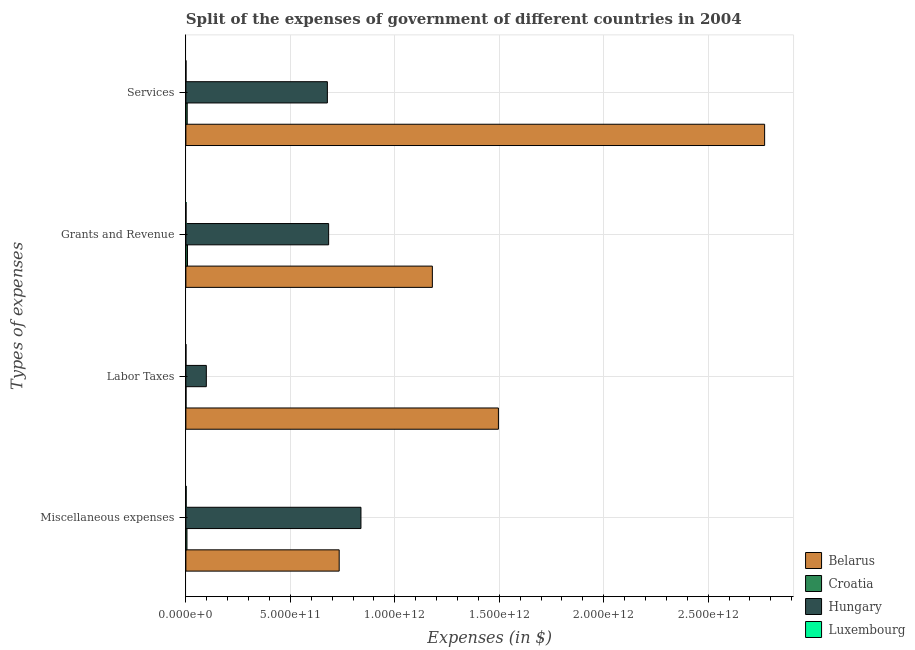How many different coloured bars are there?
Provide a succinct answer. 4. How many groups of bars are there?
Your answer should be compact. 4. Are the number of bars on each tick of the Y-axis equal?
Offer a terse response. Yes. What is the label of the 3rd group of bars from the top?
Provide a short and direct response. Labor Taxes. What is the amount spent on labor taxes in Croatia?
Your answer should be compact. 6.97e+08. Across all countries, what is the maximum amount spent on grants and revenue?
Keep it short and to the point. 1.18e+12. Across all countries, what is the minimum amount spent on services?
Your answer should be compact. 6.20e+08. In which country was the amount spent on grants and revenue maximum?
Your answer should be compact. Belarus. In which country was the amount spent on services minimum?
Ensure brevity in your answer.  Luxembourg. What is the total amount spent on grants and revenue in the graph?
Make the answer very short. 1.87e+12. What is the difference between the amount spent on labor taxes in Hungary and that in Croatia?
Your answer should be very brief. 9.72e+1. What is the difference between the amount spent on miscellaneous expenses in Luxembourg and the amount spent on services in Croatia?
Offer a terse response. -4.93e+09. What is the average amount spent on services per country?
Offer a very short reply. 8.64e+11. What is the difference between the amount spent on grants and revenue and amount spent on services in Croatia?
Your response must be concise. 1.38e+09. In how many countries, is the amount spent on miscellaneous expenses greater than 1000000000000 $?
Your response must be concise. 0. What is the ratio of the amount spent on miscellaneous expenses in Luxembourg to that in Hungary?
Your answer should be compact. 0. Is the amount spent on labor taxes in Belarus less than that in Croatia?
Provide a succinct answer. No. Is the difference between the amount spent on services in Croatia and Luxembourg greater than the difference between the amount spent on labor taxes in Croatia and Luxembourg?
Provide a succinct answer. Yes. What is the difference between the highest and the second highest amount spent on miscellaneous expenses?
Your response must be concise. 1.04e+11. What is the difference between the highest and the lowest amount spent on services?
Keep it short and to the point. 2.77e+12. In how many countries, is the amount spent on services greater than the average amount spent on services taken over all countries?
Offer a terse response. 1. Is the sum of the amount spent on miscellaneous expenses in Belarus and Luxembourg greater than the maximum amount spent on services across all countries?
Your response must be concise. No. Is it the case that in every country, the sum of the amount spent on grants and revenue and amount spent on miscellaneous expenses is greater than the sum of amount spent on labor taxes and amount spent on services?
Keep it short and to the point. Yes. What does the 1st bar from the top in Labor Taxes represents?
Provide a succinct answer. Luxembourg. What does the 1st bar from the bottom in Grants and Revenue represents?
Provide a succinct answer. Belarus. How many bars are there?
Your response must be concise. 16. What is the difference between two consecutive major ticks on the X-axis?
Ensure brevity in your answer.  5.00e+11. Are the values on the major ticks of X-axis written in scientific E-notation?
Provide a succinct answer. Yes. Does the graph contain any zero values?
Give a very brief answer. No. How many legend labels are there?
Provide a short and direct response. 4. How are the legend labels stacked?
Give a very brief answer. Vertical. What is the title of the graph?
Give a very brief answer. Split of the expenses of government of different countries in 2004. Does "Gabon" appear as one of the legend labels in the graph?
Offer a very short reply. No. What is the label or title of the X-axis?
Ensure brevity in your answer.  Expenses (in $). What is the label or title of the Y-axis?
Keep it short and to the point. Types of expenses. What is the Expenses (in $) of Belarus in Miscellaneous expenses?
Offer a very short reply. 7.34e+11. What is the Expenses (in $) in Croatia in Miscellaneous expenses?
Your answer should be very brief. 5.23e+09. What is the Expenses (in $) of Hungary in Miscellaneous expenses?
Offer a terse response. 8.38e+11. What is the Expenses (in $) in Luxembourg in Miscellaneous expenses?
Offer a terse response. 1.39e+09. What is the Expenses (in $) in Belarus in Labor Taxes?
Your answer should be compact. 1.50e+12. What is the Expenses (in $) of Croatia in Labor Taxes?
Keep it short and to the point. 6.97e+08. What is the Expenses (in $) in Hungary in Labor Taxes?
Provide a succinct answer. 9.79e+1. What is the Expenses (in $) in Luxembourg in Labor Taxes?
Provide a succinct answer. 3.72e+08. What is the Expenses (in $) of Belarus in Grants and Revenue?
Ensure brevity in your answer.  1.18e+12. What is the Expenses (in $) in Croatia in Grants and Revenue?
Give a very brief answer. 7.71e+09. What is the Expenses (in $) in Hungary in Grants and Revenue?
Make the answer very short. 6.83e+11. What is the Expenses (in $) in Luxembourg in Grants and Revenue?
Provide a succinct answer. 7.38e+08. What is the Expenses (in $) in Belarus in Services?
Provide a succinct answer. 2.77e+12. What is the Expenses (in $) of Croatia in Services?
Ensure brevity in your answer.  6.33e+09. What is the Expenses (in $) of Hungary in Services?
Your answer should be compact. 6.77e+11. What is the Expenses (in $) in Luxembourg in Services?
Provide a short and direct response. 6.20e+08. Across all Types of expenses, what is the maximum Expenses (in $) in Belarus?
Your response must be concise. 2.77e+12. Across all Types of expenses, what is the maximum Expenses (in $) in Croatia?
Provide a succinct answer. 7.71e+09. Across all Types of expenses, what is the maximum Expenses (in $) in Hungary?
Provide a short and direct response. 8.38e+11. Across all Types of expenses, what is the maximum Expenses (in $) in Luxembourg?
Ensure brevity in your answer.  1.39e+09. Across all Types of expenses, what is the minimum Expenses (in $) of Belarus?
Keep it short and to the point. 7.34e+11. Across all Types of expenses, what is the minimum Expenses (in $) of Croatia?
Your answer should be compact. 6.97e+08. Across all Types of expenses, what is the minimum Expenses (in $) in Hungary?
Your answer should be very brief. 9.79e+1. Across all Types of expenses, what is the minimum Expenses (in $) in Luxembourg?
Provide a succinct answer. 3.72e+08. What is the total Expenses (in $) of Belarus in the graph?
Make the answer very short. 6.18e+12. What is the total Expenses (in $) of Croatia in the graph?
Keep it short and to the point. 2.00e+1. What is the total Expenses (in $) in Hungary in the graph?
Offer a very short reply. 2.30e+12. What is the total Expenses (in $) in Luxembourg in the graph?
Your response must be concise. 3.12e+09. What is the difference between the Expenses (in $) in Belarus in Miscellaneous expenses and that in Labor Taxes?
Keep it short and to the point. -7.62e+11. What is the difference between the Expenses (in $) of Croatia in Miscellaneous expenses and that in Labor Taxes?
Make the answer very short. 4.53e+09. What is the difference between the Expenses (in $) in Hungary in Miscellaneous expenses and that in Labor Taxes?
Your answer should be very brief. 7.40e+11. What is the difference between the Expenses (in $) of Luxembourg in Miscellaneous expenses and that in Labor Taxes?
Your response must be concise. 1.02e+09. What is the difference between the Expenses (in $) of Belarus in Miscellaneous expenses and that in Grants and Revenue?
Offer a very short reply. -4.46e+11. What is the difference between the Expenses (in $) in Croatia in Miscellaneous expenses and that in Grants and Revenue?
Your response must be concise. -2.48e+09. What is the difference between the Expenses (in $) in Hungary in Miscellaneous expenses and that in Grants and Revenue?
Your answer should be compact. 1.55e+11. What is the difference between the Expenses (in $) of Luxembourg in Miscellaneous expenses and that in Grants and Revenue?
Offer a terse response. 6.57e+08. What is the difference between the Expenses (in $) of Belarus in Miscellaneous expenses and that in Services?
Keep it short and to the point. -2.04e+12. What is the difference between the Expenses (in $) in Croatia in Miscellaneous expenses and that in Services?
Make the answer very short. -1.10e+09. What is the difference between the Expenses (in $) in Hungary in Miscellaneous expenses and that in Services?
Give a very brief answer. 1.61e+11. What is the difference between the Expenses (in $) of Luxembourg in Miscellaneous expenses and that in Services?
Your answer should be very brief. 7.75e+08. What is the difference between the Expenses (in $) of Belarus in Labor Taxes and that in Grants and Revenue?
Your answer should be compact. 3.16e+11. What is the difference between the Expenses (in $) in Croatia in Labor Taxes and that in Grants and Revenue?
Ensure brevity in your answer.  -7.01e+09. What is the difference between the Expenses (in $) of Hungary in Labor Taxes and that in Grants and Revenue?
Your answer should be very brief. -5.86e+11. What is the difference between the Expenses (in $) of Luxembourg in Labor Taxes and that in Grants and Revenue?
Your answer should be very brief. -3.66e+08. What is the difference between the Expenses (in $) in Belarus in Labor Taxes and that in Services?
Keep it short and to the point. -1.27e+12. What is the difference between the Expenses (in $) of Croatia in Labor Taxes and that in Services?
Offer a terse response. -5.63e+09. What is the difference between the Expenses (in $) in Hungary in Labor Taxes and that in Services?
Offer a terse response. -5.79e+11. What is the difference between the Expenses (in $) of Luxembourg in Labor Taxes and that in Services?
Your answer should be compact. -2.48e+08. What is the difference between the Expenses (in $) of Belarus in Grants and Revenue and that in Services?
Your response must be concise. -1.59e+12. What is the difference between the Expenses (in $) in Croatia in Grants and Revenue and that in Services?
Keep it short and to the point. 1.38e+09. What is the difference between the Expenses (in $) of Hungary in Grants and Revenue and that in Services?
Provide a succinct answer. 6.04e+09. What is the difference between the Expenses (in $) in Luxembourg in Grants and Revenue and that in Services?
Your response must be concise. 1.18e+08. What is the difference between the Expenses (in $) of Belarus in Miscellaneous expenses and the Expenses (in $) of Croatia in Labor Taxes?
Offer a very short reply. 7.33e+11. What is the difference between the Expenses (in $) in Belarus in Miscellaneous expenses and the Expenses (in $) in Hungary in Labor Taxes?
Offer a very short reply. 6.36e+11. What is the difference between the Expenses (in $) of Belarus in Miscellaneous expenses and the Expenses (in $) of Luxembourg in Labor Taxes?
Your answer should be compact. 7.34e+11. What is the difference between the Expenses (in $) of Croatia in Miscellaneous expenses and the Expenses (in $) of Hungary in Labor Taxes?
Offer a very short reply. -9.27e+1. What is the difference between the Expenses (in $) in Croatia in Miscellaneous expenses and the Expenses (in $) in Luxembourg in Labor Taxes?
Your answer should be very brief. 4.86e+09. What is the difference between the Expenses (in $) of Hungary in Miscellaneous expenses and the Expenses (in $) of Luxembourg in Labor Taxes?
Provide a short and direct response. 8.38e+11. What is the difference between the Expenses (in $) in Belarus in Miscellaneous expenses and the Expenses (in $) in Croatia in Grants and Revenue?
Your answer should be compact. 7.26e+11. What is the difference between the Expenses (in $) of Belarus in Miscellaneous expenses and the Expenses (in $) of Hungary in Grants and Revenue?
Provide a succinct answer. 5.05e+1. What is the difference between the Expenses (in $) of Belarus in Miscellaneous expenses and the Expenses (in $) of Luxembourg in Grants and Revenue?
Your answer should be very brief. 7.33e+11. What is the difference between the Expenses (in $) in Croatia in Miscellaneous expenses and the Expenses (in $) in Hungary in Grants and Revenue?
Give a very brief answer. -6.78e+11. What is the difference between the Expenses (in $) in Croatia in Miscellaneous expenses and the Expenses (in $) in Luxembourg in Grants and Revenue?
Provide a short and direct response. 4.49e+09. What is the difference between the Expenses (in $) in Hungary in Miscellaneous expenses and the Expenses (in $) in Luxembourg in Grants and Revenue?
Offer a terse response. 8.37e+11. What is the difference between the Expenses (in $) of Belarus in Miscellaneous expenses and the Expenses (in $) of Croatia in Services?
Offer a terse response. 7.28e+11. What is the difference between the Expenses (in $) in Belarus in Miscellaneous expenses and the Expenses (in $) in Hungary in Services?
Provide a short and direct response. 5.65e+1. What is the difference between the Expenses (in $) of Belarus in Miscellaneous expenses and the Expenses (in $) of Luxembourg in Services?
Provide a short and direct response. 7.33e+11. What is the difference between the Expenses (in $) of Croatia in Miscellaneous expenses and the Expenses (in $) of Hungary in Services?
Give a very brief answer. -6.72e+11. What is the difference between the Expenses (in $) in Croatia in Miscellaneous expenses and the Expenses (in $) in Luxembourg in Services?
Offer a very short reply. 4.61e+09. What is the difference between the Expenses (in $) in Hungary in Miscellaneous expenses and the Expenses (in $) in Luxembourg in Services?
Ensure brevity in your answer.  8.37e+11. What is the difference between the Expenses (in $) in Belarus in Labor Taxes and the Expenses (in $) in Croatia in Grants and Revenue?
Your answer should be very brief. 1.49e+12. What is the difference between the Expenses (in $) of Belarus in Labor Taxes and the Expenses (in $) of Hungary in Grants and Revenue?
Offer a very short reply. 8.13e+11. What is the difference between the Expenses (in $) in Belarus in Labor Taxes and the Expenses (in $) in Luxembourg in Grants and Revenue?
Your answer should be very brief. 1.50e+12. What is the difference between the Expenses (in $) of Croatia in Labor Taxes and the Expenses (in $) of Hungary in Grants and Revenue?
Your answer should be very brief. -6.83e+11. What is the difference between the Expenses (in $) of Croatia in Labor Taxes and the Expenses (in $) of Luxembourg in Grants and Revenue?
Offer a very short reply. -4.07e+07. What is the difference between the Expenses (in $) in Hungary in Labor Taxes and the Expenses (in $) in Luxembourg in Grants and Revenue?
Your answer should be compact. 9.72e+1. What is the difference between the Expenses (in $) of Belarus in Labor Taxes and the Expenses (in $) of Croatia in Services?
Your answer should be compact. 1.49e+12. What is the difference between the Expenses (in $) of Belarus in Labor Taxes and the Expenses (in $) of Hungary in Services?
Offer a terse response. 8.19e+11. What is the difference between the Expenses (in $) in Belarus in Labor Taxes and the Expenses (in $) in Luxembourg in Services?
Offer a very short reply. 1.50e+12. What is the difference between the Expenses (in $) in Croatia in Labor Taxes and the Expenses (in $) in Hungary in Services?
Offer a very short reply. -6.77e+11. What is the difference between the Expenses (in $) of Croatia in Labor Taxes and the Expenses (in $) of Luxembourg in Services?
Keep it short and to the point. 7.73e+07. What is the difference between the Expenses (in $) in Hungary in Labor Taxes and the Expenses (in $) in Luxembourg in Services?
Offer a very short reply. 9.73e+1. What is the difference between the Expenses (in $) of Belarus in Grants and Revenue and the Expenses (in $) of Croatia in Services?
Provide a short and direct response. 1.17e+12. What is the difference between the Expenses (in $) in Belarus in Grants and Revenue and the Expenses (in $) in Hungary in Services?
Keep it short and to the point. 5.03e+11. What is the difference between the Expenses (in $) in Belarus in Grants and Revenue and the Expenses (in $) in Luxembourg in Services?
Keep it short and to the point. 1.18e+12. What is the difference between the Expenses (in $) in Croatia in Grants and Revenue and the Expenses (in $) in Hungary in Services?
Keep it short and to the point. -6.70e+11. What is the difference between the Expenses (in $) in Croatia in Grants and Revenue and the Expenses (in $) in Luxembourg in Services?
Provide a succinct answer. 7.09e+09. What is the difference between the Expenses (in $) of Hungary in Grants and Revenue and the Expenses (in $) of Luxembourg in Services?
Ensure brevity in your answer.  6.83e+11. What is the average Expenses (in $) in Belarus per Types of expenses?
Your answer should be very brief. 1.55e+12. What is the average Expenses (in $) of Croatia per Types of expenses?
Offer a very short reply. 4.99e+09. What is the average Expenses (in $) of Hungary per Types of expenses?
Offer a very short reply. 5.74e+11. What is the average Expenses (in $) in Luxembourg per Types of expenses?
Make the answer very short. 7.81e+08. What is the difference between the Expenses (in $) in Belarus and Expenses (in $) in Croatia in Miscellaneous expenses?
Ensure brevity in your answer.  7.29e+11. What is the difference between the Expenses (in $) in Belarus and Expenses (in $) in Hungary in Miscellaneous expenses?
Offer a very short reply. -1.04e+11. What is the difference between the Expenses (in $) in Belarus and Expenses (in $) in Luxembourg in Miscellaneous expenses?
Give a very brief answer. 7.33e+11. What is the difference between the Expenses (in $) of Croatia and Expenses (in $) of Hungary in Miscellaneous expenses?
Make the answer very short. -8.33e+11. What is the difference between the Expenses (in $) in Croatia and Expenses (in $) in Luxembourg in Miscellaneous expenses?
Provide a succinct answer. 3.83e+09. What is the difference between the Expenses (in $) in Hungary and Expenses (in $) in Luxembourg in Miscellaneous expenses?
Your answer should be compact. 8.37e+11. What is the difference between the Expenses (in $) of Belarus and Expenses (in $) of Croatia in Labor Taxes?
Your answer should be very brief. 1.50e+12. What is the difference between the Expenses (in $) in Belarus and Expenses (in $) in Hungary in Labor Taxes?
Make the answer very short. 1.40e+12. What is the difference between the Expenses (in $) of Belarus and Expenses (in $) of Luxembourg in Labor Taxes?
Offer a very short reply. 1.50e+12. What is the difference between the Expenses (in $) in Croatia and Expenses (in $) in Hungary in Labor Taxes?
Your response must be concise. -9.72e+1. What is the difference between the Expenses (in $) of Croatia and Expenses (in $) of Luxembourg in Labor Taxes?
Keep it short and to the point. 3.26e+08. What is the difference between the Expenses (in $) in Hungary and Expenses (in $) in Luxembourg in Labor Taxes?
Offer a terse response. 9.75e+1. What is the difference between the Expenses (in $) of Belarus and Expenses (in $) of Croatia in Grants and Revenue?
Your response must be concise. 1.17e+12. What is the difference between the Expenses (in $) in Belarus and Expenses (in $) in Hungary in Grants and Revenue?
Your answer should be very brief. 4.96e+11. What is the difference between the Expenses (in $) in Belarus and Expenses (in $) in Luxembourg in Grants and Revenue?
Your answer should be very brief. 1.18e+12. What is the difference between the Expenses (in $) in Croatia and Expenses (in $) in Hungary in Grants and Revenue?
Your answer should be very brief. -6.76e+11. What is the difference between the Expenses (in $) of Croatia and Expenses (in $) of Luxembourg in Grants and Revenue?
Make the answer very short. 6.97e+09. What is the difference between the Expenses (in $) in Hungary and Expenses (in $) in Luxembourg in Grants and Revenue?
Offer a terse response. 6.83e+11. What is the difference between the Expenses (in $) of Belarus and Expenses (in $) of Croatia in Services?
Make the answer very short. 2.76e+12. What is the difference between the Expenses (in $) of Belarus and Expenses (in $) of Hungary in Services?
Give a very brief answer. 2.09e+12. What is the difference between the Expenses (in $) of Belarus and Expenses (in $) of Luxembourg in Services?
Provide a short and direct response. 2.77e+12. What is the difference between the Expenses (in $) in Croatia and Expenses (in $) in Hungary in Services?
Your answer should be compact. -6.71e+11. What is the difference between the Expenses (in $) of Croatia and Expenses (in $) of Luxembourg in Services?
Provide a short and direct response. 5.71e+09. What is the difference between the Expenses (in $) in Hungary and Expenses (in $) in Luxembourg in Services?
Your answer should be very brief. 6.77e+11. What is the ratio of the Expenses (in $) in Belarus in Miscellaneous expenses to that in Labor Taxes?
Your response must be concise. 0.49. What is the ratio of the Expenses (in $) in Croatia in Miscellaneous expenses to that in Labor Taxes?
Offer a terse response. 7.5. What is the ratio of the Expenses (in $) of Hungary in Miscellaneous expenses to that in Labor Taxes?
Keep it short and to the point. 8.56. What is the ratio of the Expenses (in $) in Luxembourg in Miscellaneous expenses to that in Labor Taxes?
Your answer should be compact. 3.75. What is the ratio of the Expenses (in $) of Belarus in Miscellaneous expenses to that in Grants and Revenue?
Your answer should be very brief. 0.62. What is the ratio of the Expenses (in $) of Croatia in Miscellaneous expenses to that in Grants and Revenue?
Your answer should be very brief. 0.68. What is the ratio of the Expenses (in $) in Hungary in Miscellaneous expenses to that in Grants and Revenue?
Offer a terse response. 1.23. What is the ratio of the Expenses (in $) of Luxembourg in Miscellaneous expenses to that in Grants and Revenue?
Keep it short and to the point. 1.89. What is the ratio of the Expenses (in $) of Belarus in Miscellaneous expenses to that in Services?
Your answer should be compact. 0.26. What is the ratio of the Expenses (in $) of Croatia in Miscellaneous expenses to that in Services?
Keep it short and to the point. 0.83. What is the ratio of the Expenses (in $) in Hungary in Miscellaneous expenses to that in Services?
Ensure brevity in your answer.  1.24. What is the ratio of the Expenses (in $) in Luxembourg in Miscellaneous expenses to that in Services?
Give a very brief answer. 2.25. What is the ratio of the Expenses (in $) of Belarus in Labor Taxes to that in Grants and Revenue?
Your answer should be very brief. 1.27. What is the ratio of the Expenses (in $) in Croatia in Labor Taxes to that in Grants and Revenue?
Make the answer very short. 0.09. What is the ratio of the Expenses (in $) of Hungary in Labor Taxes to that in Grants and Revenue?
Ensure brevity in your answer.  0.14. What is the ratio of the Expenses (in $) of Luxembourg in Labor Taxes to that in Grants and Revenue?
Offer a very short reply. 0.5. What is the ratio of the Expenses (in $) in Belarus in Labor Taxes to that in Services?
Provide a short and direct response. 0.54. What is the ratio of the Expenses (in $) in Croatia in Labor Taxes to that in Services?
Your response must be concise. 0.11. What is the ratio of the Expenses (in $) in Hungary in Labor Taxes to that in Services?
Your response must be concise. 0.14. What is the ratio of the Expenses (in $) in Luxembourg in Labor Taxes to that in Services?
Your answer should be very brief. 0.6. What is the ratio of the Expenses (in $) of Belarus in Grants and Revenue to that in Services?
Your answer should be very brief. 0.43. What is the ratio of the Expenses (in $) in Croatia in Grants and Revenue to that in Services?
Offer a terse response. 1.22. What is the ratio of the Expenses (in $) of Hungary in Grants and Revenue to that in Services?
Offer a terse response. 1.01. What is the ratio of the Expenses (in $) of Luxembourg in Grants and Revenue to that in Services?
Offer a very short reply. 1.19. What is the difference between the highest and the second highest Expenses (in $) of Belarus?
Your response must be concise. 1.27e+12. What is the difference between the highest and the second highest Expenses (in $) of Croatia?
Your response must be concise. 1.38e+09. What is the difference between the highest and the second highest Expenses (in $) in Hungary?
Provide a short and direct response. 1.55e+11. What is the difference between the highest and the second highest Expenses (in $) in Luxembourg?
Your response must be concise. 6.57e+08. What is the difference between the highest and the lowest Expenses (in $) in Belarus?
Provide a short and direct response. 2.04e+12. What is the difference between the highest and the lowest Expenses (in $) in Croatia?
Your response must be concise. 7.01e+09. What is the difference between the highest and the lowest Expenses (in $) in Hungary?
Offer a very short reply. 7.40e+11. What is the difference between the highest and the lowest Expenses (in $) in Luxembourg?
Provide a short and direct response. 1.02e+09. 